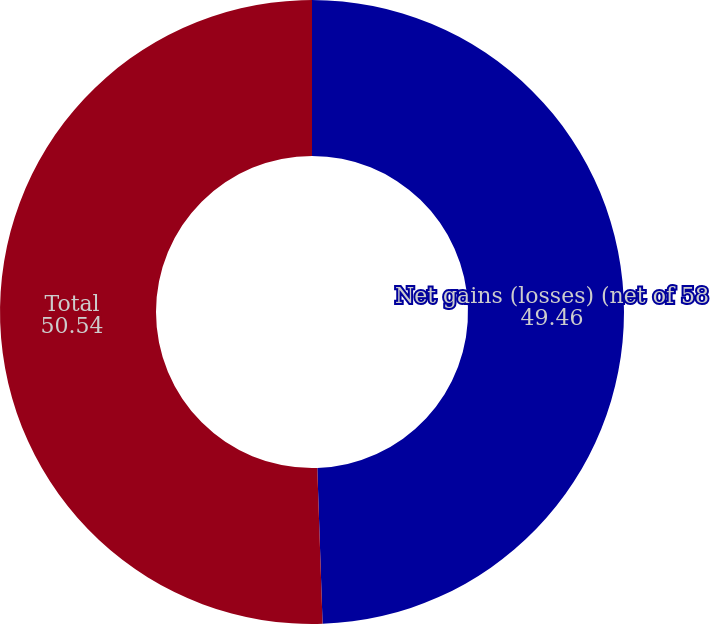Convert chart. <chart><loc_0><loc_0><loc_500><loc_500><pie_chart><fcel>Net gains (losses) (net of 58<fcel>Total<nl><fcel>49.46%<fcel>50.54%<nl></chart> 